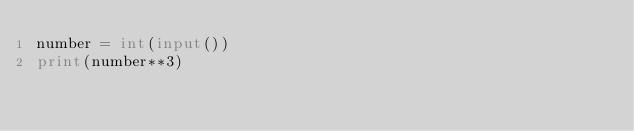Convert code to text. <code><loc_0><loc_0><loc_500><loc_500><_Python_>number = int(input())
print(number**3)

</code> 